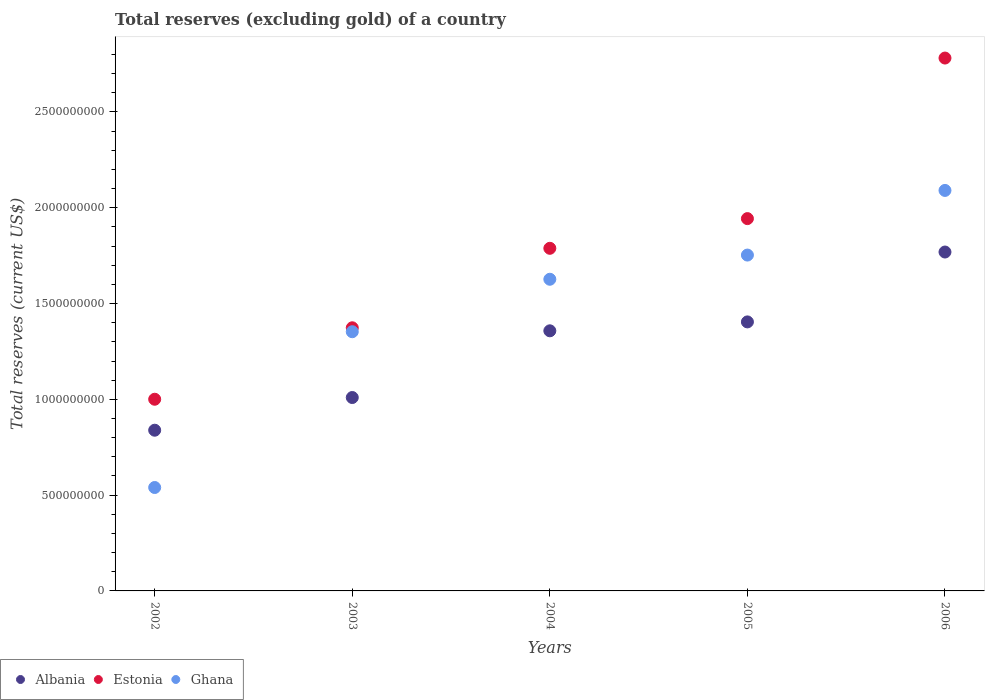How many different coloured dotlines are there?
Your answer should be compact. 3. What is the total reserves (excluding gold) in Ghana in 2003?
Give a very brief answer. 1.35e+09. Across all years, what is the maximum total reserves (excluding gold) in Estonia?
Your answer should be compact. 2.78e+09. Across all years, what is the minimum total reserves (excluding gold) in Estonia?
Make the answer very short. 1.00e+09. In which year was the total reserves (excluding gold) in Ghana maximum?
Offer a very short reply. 2006. In which year was the total reserves (excluding gold) in Ghana minimum?
Offer a terse response. 2002. What is the total total reserves (excluding gold) in Estonia in the graph?
Your response must be concise. 8.89e+09. What is the difference between the total reserves (excluding gold) in Albania in 2002 and that in 2005?
Your answer should be very brief. -5.65e+08. What is the difference between the total reserves (excluding gold) in Albania in 2004 and the total reserves (excluding gold) in Ghana in 2005?
Offer a terse response. -3.95e+08. What is the average total reserves (excluding gold) in Ghana per year?
Make the answer very short. 1.47e+09. In the year 2002, what is the difference between the total reserves (excluding gold) in Ghana and total reserves (excluding gold) in Estonia?
Your response must be concise. -4.61e+08. What is the ratio of the total reserves (excluding gold) in Estonia in 2002 to that in 2003?
Make the answer very short. 0.73. Is the total reserves (excluding gold) in Ghana in 2002 less than that in 2003?
Your response must be concise. Yes. Is the difference between the total reserves (excluding gold) in Ghana in 2002 and 2004 greater than the difference between the total reserves (excluding gold) in Estonia in 2002 and 2004?
Ensure brevity in your answer.  No. What is the difference between the highest and the second highest total reserves (excluding gold) in Ghana?
Your response must be concise. 3.37e+08. What is the difference between the highest and the lowest total reserves (excluding gold) in Estonia?
Your answer should be very brief. 1.78e+09. In how many years, is the total reserves (excluding gold) in Albania greater than the average total reserves (excluding gold) in Albania taken over all years?
Offer a very short reply. 3. Is the sum of the total reserves (excluding gold) in Albania in 2002 and 2003 greater than the maximum total reserves (excluding gold) in Estonia across all years?
Provide a short and direct response. No. Is the total reserves (excluding gold) in Albania strictly less than the total reserves (excluding gold) in Estonia over the years?
Your answer should be very brief. Yes. How many dotlines are there?
Offer a terse response. 3. What is the difference between two consecutive major ticks on the Y-axis?
Make the answer very short. 5.00e+08. Are the values on the major ticks of Y-axis written in scientific E-notation?
Provide a succinct answer. No. Does the graph contain any zero values?
Keep it short and to the point. No. What is the title of the graph?
Ensure brevity in your answer.  Total reserves (excluding gold) of a country. What is the label or title of the Y-axis?
Your answer should be compact. Total reserves (current US$). What is the Total reserves (current US$) in Albania in 2002?
Offer a terse response. 8.39e+08. What is the Total reserves (current US$) in Estonia in 2002?
Provide a succinct answer. 1.00e+09. What is the Total reserves (current US$) of Ghana in 2002?
Offer a very short reply. 5.40e+08. What is the Total reserves (current US$) in Albania in 2003?
Keep it short and to the point. 1.01e+09. What is the Total reserves (current US$) in Estonia in 2003?
Provide a short and direct response. 1.37e+09. What is the Total reserves (current US$) in Ghana in 2003?
Your answer should be very brief. 1.35e+09. What is the Total reserves (current US$) of Albania in 2004?
Make the answer very short. 1.36e+09. What is the Total reserves (current US$) of Estonia in 2004?
Your answer should be very brief. 1.79e+09. What is the Total reserves (current US$) of Ghana in 2004?
Offer a terse response. 1.63e+09. What is the Total reserves (current US$) of Albania in 2005?
Keep it short and to the point. 1.40e+09. What is the Total reserves (current US$) of Estonia in 2005?
Your answer should be very brief. 1.94e+09. What is the Total reserves (current US$) in Ghana in 2005?
Your response must be concise. 1.75e+09. What is the Total reserves (current US$) of Albania in 2006?
Your response must be concise. 1.77e+09. What is the Total reserves (current US$) of Estonia in 2006?
Make the answer very short. 2.78e+09. What is the Total reserves (current US$) in Ghana in 2006?
Offer a very short reply. 2.09e+09. Across all years, what is the maximum Total reserves (current US$) in Albania?
Provide a short and direct response. 1.77e+09. Across all years, what is the maximum Total reserves (current US$) of Estonia?
Make the answer very short. 2.78e+09. Across all years, what is the maximum Total reserves (current US$) in Ghana?
Your response must be concise. 2.09e+09. Across all years, what is the minimum Total reserves (current US$) of Albania?
Provide a short and direct response. 8.39e+08. Across all years, what is the minimum Total reserves (current US$) in Estonia?
Provide a short and direct response. 1.00e+09. Across all years, what is the minimum Total reserves (current US$) in Ghana?
Offer a terse response. 5.40e+08. What is the total Total reserves (current US$) of Albania in the graph?
Provide a short and direct response. 6.38e+09. What is the total Total reserves (current US$) of Estonia in the graph?
Your answer should be very brief. 8.89e+09. What is the total Total reserves (current US$) of Ghana in the graph?
Your response must be concise. 7.36e+09. What is the difference between the Total reserves (current US$) in Albania in 2002 and that in 2003?
Keep it short and to the point. -1.71e+08. What is the difference between the Total reserves (current US$) in Estonia in 2002 and that in 2003?
Keep it short and to the point. -3.73e+08. What is the difference between the Total reserves (current US$) in Ghana in 2002 and that in 2003?
Keep it short and to the point. -8.13e+08. What is the difference between the Total reserves (current US$) of Albania in 2002 and that in 2004?
Offer a very short reply. -5.19e+08. What is the difference between the Total reserves (current US$) of Estonia in 2002 and that in 2004?
Provide a short and direct response. -7.88e+08. What is the difference between the Total reserves (current US$) in Ghana in 2002 and that in 2004?
Your response must be concise. -1.09e+09. What is the difference between the Total reserves (current US$) of Albania in 2002 and that in 2005?
Make the answer very short. -5.65e+08. What is the difference between the Total reserves (current US$) of Estonia in 2002 and that in 2005?
Your response must be concise. -9.43e+08. What is the difference between the Total reserves (current US$) in Ghana in 2002 and that in 2005?
Provide a succinct answer. -1.21e+09. What is the difference between the Total reserves (current US$) of Albania in 2002 and that in 2006?
Your answer should be compact. -9.30e+08. What is the difference between the Total reserves (current US$) of Estonia in 2002 and that in 2006?
Offer a terse response. -1.78e+09. What is the difference between the Total reserves (current US$) in Ghana in 2002 and that in 2006?
Your answer should be very brief. -1.55e+09. What is the difference between the Total reserves (current US$) in Albania in 2003 and that in 2004?
Keep it short and to the point. -3.48e+08. What is the difference between the Total reserves (current US$) in Estonia in 2003 and that in 2004?
Ensure brevity in your answer.  -4.15e+08. What is the difference between the Total reserves (current US$) of Ghana in 2003 and that in 2004?
Offer a very short reply. -2.74e+08. What is the difference between the Total reserves (current US$) in Albania in 2003 and that in 2005?
Offer a very short reply. -3.95e+08. What is the difference between the Total reserves (current US$) of Estonia in 2003 and that in 2005?
Provide a short and direct response. -5.70e+08. What is the difference between the Total reserves (current US$) of Ghana in 2003 and that in 2005?
Provide a short and direct response. -4.00e+08. What is the difference between the Total reserves (current US$) in Albania in 2003 and that in 2006?
Your answer should be very brief. -7.59e+08. What is the difference between the Total reserves (current US$) in Estonia in 2003 and that in 2006?
Your response must be concise. -1.41e+09. What is the difference between the Total reserves (current US$) of Ghana in 2003 and that in 2006?
Your response must be concise. -7.37e+08. What is the difference between the Total reserves (current US$) of Albania in 2004 and that in 2005?
Make the answer very short. -4.65e+07. What is the difference between the Total reserves (current US$) of Estonia in 2004 and that in 2005?
Your answer should be very brief. -1.55e+08. What is the difference between the Total reserves (current US$) of Ghana in 2004 and that in 2005?
Give a very brief answer. -1.26e+08. What is the difference between the Total reserves (current US$) of Albania in 2004 and that in 2006?
Keep it short and to the point. -4.11e+08. What is the difference between the Total reserves (current US$) of Estonia in 2004 and that in 2006?
Your answer should be compact. -9.93e+08. What is the difference between the Total reserves (current US$) in Ghana in 2004 and that in 2006?
Your answer should be compact. -4.64e+08. What is the difference between the Total reserves (current US$) of Albania in 2005 and that in 2006?
Ensure brevity in your answer.  -3.65e+08. What is the difference between the Total reserves (current US$) in Estonia in 2005 and that in 2006?
Your answer should be compact. -8.38e+08. What is the difference between the Total reserves (current US$) in Ghana in 2005 and that in 2006?
Your response must be concise. -3.37e+08. What is the difference between the Total reserves (current US$) in Albania in 2002 and the Total reserves (current US$) in Estonia in 2003?
Your answer should be very brief. -5.35e+08. What is the difference between the Total reserves (current US$) in Albania in 2002 and the Total reserves (current US$) in Ghana in 2003?
Provide a short and direct response. -5.14e+08. What is the difference between the Total reserves (current US$) in Estonia in 2002 and the Total reserves (current US$) in Ghana in 2003?
Provide a succinct answer. -3.52e+08. What is the difference between the Total reserves (current US$) in Albania in 2002 and the Total reserves (current US$) in Estonia in 2004?
Provide a succinct answer. -9.49e+08. What is the difference between the Total reserves (current US$) of Albania in 2002 and the Total reserves (current US$) of Ghana in 2004?
Offer a very short reply. -7.88e+08. What is the difference between the Total reserves (current US$) in Estonia in 2002 and the Total reserves (current US$) in Ghana in 2004?
Make the answer very short. -6.26e+08. What is the difference between the Total reserves (current US$) in Albania in 2002 and the Total reserves (current US$) in Estonia in 2005?
Your answer should be compact. -1.10e+09. What is the difference between the Total reserves (current US$) of Albania in 2002 and the Total reserves (current US$) of Ghana in 2005?
Your answer should be compact. -9.14e+08. What is the difference between the Total reserves (current US$) in Estonia in 2002 and the Total reserves (current US$) in Ghana in 2005?
Your answer should be compact. -7.52e+08. What is the difference between the Total reserves (current US$) of Albania in 2002 and the Total reserves (current US$) of Estonia in 2006?
Keep it short and to the point. -1.94e+09. What is the difference between the Total reserves (current US$) of Albania in 2002 and the Total reserves (current US$) of Ghana in 2006?
Your answer should be very brief. -1.25e+09. What is the difference between the Total reserves (current US$) of Estonia in 2002 and the Total reserves (current US$) of Ghana in 2006?
Offer a terse response. -1.09e+09. What is the difference between the Total reserves (current US$) in Albania in 2003 and the Total reserves (current US$) in Estonia in 2004?
Ensure brevity in your answer.  -7.79e+08. What is the difference between the Total reserves (current US$) of Albania in 2003 and the Total reserves (current US$) of Ghana in 2004?
Your response must be concise. -6.17e+08. What is the difference between the Total reserves (current US$) in Estonia in 2003 and the Total reserves (current US$) in Ghana in 2004?
Offer a very short reply. -2.53e+08. What is the difference between the Total reserves (current US$) of Albania in 2003 and the Total reserves (current US$) of Estonia in 2005?
Offer a terse response. -9.34e+08. What is the difference between the Total reserves (current US$) in Albania in 2003 and the Total reserves (current US$) in Ghana in 2005?
Your answer should be compact. -7.43e+08. What is the difference between the Total reserves (current US$) of Estonia in 2003 and the Total reserves (current US$) of Ghana in 2005?
Provide a short and direct response. -3.80e+08. What is the difference between the Total reserves (current US$) in Albania in 2003 and the Total reserves (current US$) in Estonia in 2006?
Provide a succinct answer. -1.77e+09. What is the difference between the Total reserves (current US$) in Albania in 2003 and the Total reserves (current US$) in Ghana in 2006?
Your answer should be very brief. -1.08e+09. What is the difference between the Total reserves (current US$) of Estonia in 2003 and the Total reserves (current US$) of Ghana in 2006?
Your answer should be very brief. -7.17e+08. What is the difference between the Total reserves (current US$) of Albania in 2004 and the Total reserves (current US$) of Estonia in 2005?
Provide a short and direct response. -5.86e+08. What is the difference between the Total reserves (current US$) in Albania in 2004 and the Total reserves (current US$) in Ghana in 2005?
Your response must be concise. -3.95e+08. What is the difference between the Total reserves (current US$) in Estonia in 2004 and the Total reserves (current US$) in Ghana in 2005?
Keep it short and to the point. 3.53e+07. What is the difference between the Total reserves (current US$) of Albania in 2004 and the Total reserves (current US$) of Estonia in 2006?
Ensure brevity in your answer.  -1.42e+09. What is the difference between the Total reserves (current US$) of Albania in 2004 and the Total reserves (current US$) of Ghana in 2006?
Ensure brevity in your answer.  -7.33e+08. What is the difference between the Total reserves (current US$) in Estonia in 2004 and the Total reserves (current US$) in Ghana in 2006?
Ensure brevity in your answer.  -3.02e+08. What is the difference between the Total reserves (current US$) in Albania in 2005 and the Total reserves (current US$) in Estonia in 2006?
Provide a short and direct response. -1.38e+09. What is the difference between the Total reserves (current US$) of Albania in 2005 and the Total reserves (current US$) of Ghana in 2006?
Your answer should be very brief. -6.86e+08. What is the difference between the Total reserves (current US$) in Estonia in 2005 and the Total reserves (current US$) in Ghana in 2006?
Offer a terse response. -1.47e+08. What is the average Total reserves (current US$) in Albania per year?
Offer a terse response. 1.28e+09. What is the average Total reserves (current US$) of Estonia per year?
Give a very brief answer. 1.78e+09. What is the average Total reserves (current US$) of Ghana per year?
Your answer should be very brief. 1.47e+09. In the year 2002, what is the difference between the Total reserves (current US$) of Albania and Total reserves (current US$) of Estonia?
Your answer should be very brief. -1.62e+08. In the year 2002, what is the difference between the Total reserves (current US$) of Albania and Total reserves (current US$) of Ghana?
Your response must be concise. 2.99e+08. In the year 2002, what is the difference between the Total reserves (current US$) in Estonia and Total reserves (current US$) in Ghana?
Make the answer very short. 4.61e+08. In the year 2003, what is the difference between the Total reserves (current US$) of Albania and Total reserves (current US$) of Estonia?
Give a very brief answer. -3.64e+08. In the year 2003, what is the difference between the Total reserves (current US$) of Albania and Total reserves (current US$) of Ghana?
Keep it short and to the point. -3.43e+08. In the year 2003, what is the difference between the Total reserves (current US$) in Estonia and Total reserves (current US$) in Ghana?
Give a very brief answer. 2.05e+07. In the year 2004, what is the difference between the Total reserves (current US$) of Albania and Total reserves (current US$) of Estonia?
Give a very brief answer. -4.31e+08. In the year 2004, what is the difference between the Total reserves (current US$) in Albania and Total reserves (current US$) in Ghana?
Make the answer very short. -2.69e+08. In the year 2004, what is the difference between the Total reserves (current US$) in Estonia and Total reserves (current US$) in Ghana?
Your answer should be very brief. 1.62e+08. In the year 2005, what is the difference between the Total reserves (current US$) in Albania and Total reserves (current US$) in Estonia?
Offer a very short reply. -5.39e+08. In the year 2005, what is the difference between the Total reserves (current US$) of Albania and Total reserves (current US$) of Ghana?
Offer a terse response. -3.49e+08. In the year 2005, what is the difference between the Total reserves (current US$) of Estonia and Total reserves (current US$) of Ghana?
Ensure brevity in your answer.  1.90e+08. In the year 2006, what is the difference between the Total reserves (current US$) in Albania and Total reserves (current US$) in Estonia?
Provide a succinct answer. -1.01e+09. In the year 2006, what is the difference between the Total reserves (current US$) of Albania and Total reserves (current US$) of Ghana?
Ensure brevity in your answer.  -3.21e+08. In the year 2006, what is the difference between the Total reserves (current US$) in Estonia and Total reserves (current US$) in Ghana?
Keep it short and to the point. 6.91e+08. What is the ratio of the Total reserves (current US$) of Albania in 2002 to that in 2003?
Provide a short and direct response. 0.83. What is the ratio of the Total reserves (current US$) in Estonia in 2002 to that in 2003?
Make the answer very short. 0.73. What is the ratio of the Total reserves (current US$) in Ghana in 2002 to that in 2003?
Offer a terse response. 0.4. What is the ratio of the Total reserves (current US$) of Albania in 2002 to that in 2004?
Provide a succinct answer. 0.62. What is the ratio of the Total reserves (current US$) of Estonia in 2002 to that in 2004?
Your response must be concise. 0.56. What is the ratio of the Total reserves (current US$) in Ghana in 2002 to that in 2004?
Your response must be concise. 0.33. What is the ratio of the Total reserves (current US$) in Albania in 2002 to that in 2005?
Offer a terse response. 0.6. What is the ratio of the Total reserves (current US$) in Estonia in 2002 to that in 2005?
Keep it short and to the point. 0.51. What is the ratio of the Total reserves (current US$) in Ghana in 2002 to that in 2005?
Keep it short and to the point. 0.31. What is the ratio of the Total reserves (current US$) in Albania in 2002 to that in 2006?
Make the answer very short. 0.47. What is the ratio of the Total reserves (current US$) of Estonia in 2002 to that in 2006?
Your response must be concise. 0.36. What is the ratio of the Total reserves (current US$) in Ghana in 2002 to that in 2006?
Offer a very short reply. 0.26. What is the ratio of the Total reserves (current US$) of Albania in 2003 to that in 2004?
Provide a short and direct response. 0.74. What is the ratio of the Total reserves (current US$) of Estonia in 2003 to that in 2004?
Make the answer very short. 0.77. What is the ratio of the Total reserves (current US$) of Ghana in 2003 to that in 2004?
Your answer should be very brief. 0.83. What is the ratio of the Total reserves (current US$) in Albania in 2003 to that in 2005?
Ensure brevity in your answer.  0.72. What is the ratio of the Total reserves (current US$) of Estonia in 2003 to that in 2005?
Your response must be concise. 0.71. What is the ratio of the Total reserves (current US$) of Ghana in 2003 to that in 2005?
Your answer should be very brief. 0.77. What is the ratio of the Total reserves (current US$) in Albania in 2003 to that in 2006?
Your response must be concise. 0.57. What is the ratio of the Total reserves (current US$) of Estonia in 2003 to that in 2006?
Offer a terse response. 0.49. What is the ratio of the Total reserves (current US$) in Ghana in 2003 to that in 2006?
Your answer should be very brief. 0.65. What is the ratio of the Total reserves (current US$) of Albania in 2004 to that in 2005?
Give a very brief answer. 0.97. What is the ratio of the Total reserves (current US$) in Estonia in 2004 to that in 2005?
Give a very brief answer. 0.92. What is the ratio of the Total reserves (current US$) in Ghana in 2004 to that in 2005?
Make the answer very short. 0.93. What is the ratio of the Total reserves (current US$) of Albania in 2004 to that in 2006?
Provide a succinct answer. 0.77. What is the ratio of the Total reserves (current US$) of Estonia in 2004 to that in 2006?
Provide a succinct answer. 0.64. What is the ratio of the Total reserves (current US$) of Ghana in 2004 to that in 2006?
Make the answer very short. 0.78. What is the ratio of the Total reserves (current US$) of Albania in 2005 to that in 2006?
Provide a short and direct response. 0.79. What is the ratio of the Total reserves (current US$) in Estonia in 2005 to that in 2006?
Give a very brief answer. 0.7. What is the ratio of the Total reserves (current US$) in Ghana in 2005 to that in 2006?
Offer a very short reply. 0.84. What is the difference between the highest and the second highest Total reserves (current US$) in Albania?
Your answer should be compact. 3.65e+08. What is the difference between the highest and the second highest Total reserves (current US$) of Estonia?
Your response must be concise. 8.38e+08. What is the difference between the highest and the second highest Total reserves (current US$) of Ghana?
Provide a succinct answer. 3.37e+08. What is the difference between the highest and the lowest Total reserves (current US$) of Albania?
Offer a very short reply. 9.30e+08. What is the difference between the highest and the lowest Total reserves (current US$) of Estonia?
Your answer should be very brief. 1.78e+09. What is the difference between the highest and the lowest Total reserves (current US$) in Ghana?
Provide a short and direct response. 1.55e+09. 